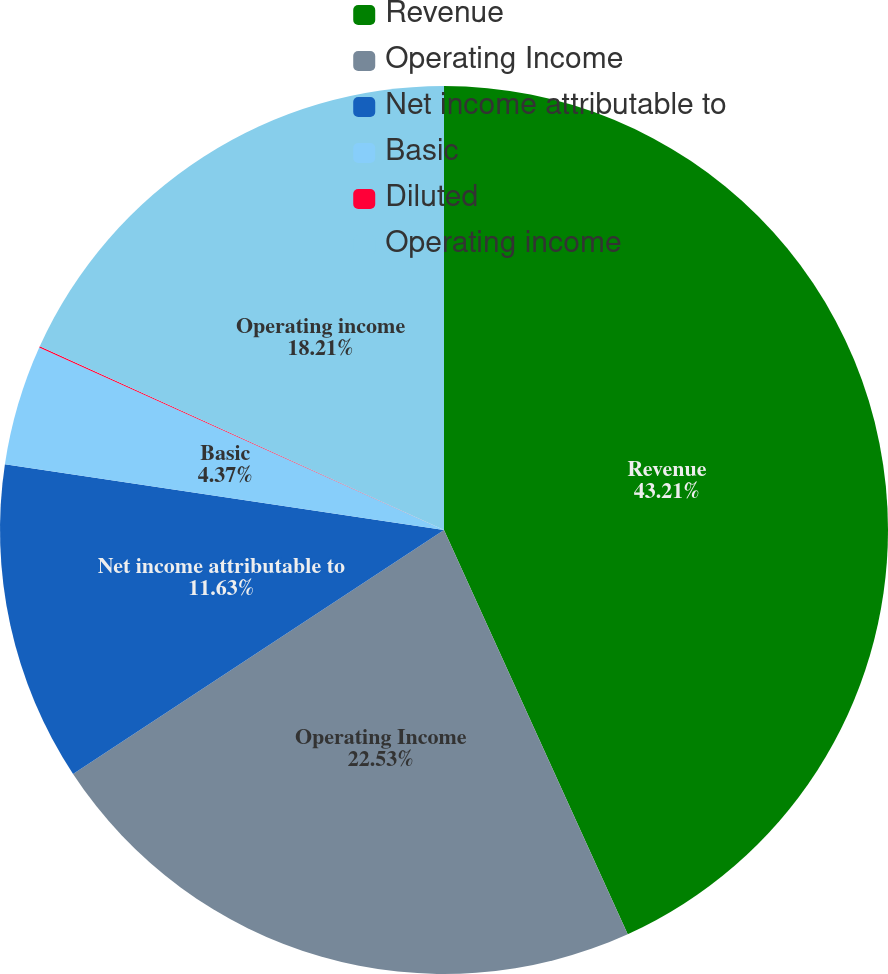Convert chart to OTSL. <chart><loc_0><loc_0><loc_500><loc_500><pie_chart><fcel>Revenue<fcel>Operating Income<fcel>Net income attributable to<fcel>Basic<fcel>Diluted<fcel>Operating income<nl><fcel>43.21%<fcel>22.53%<fcel>11.63%<fcel>4.37%<fcel>0.05%<fcel>18.21%<nl></chart> 